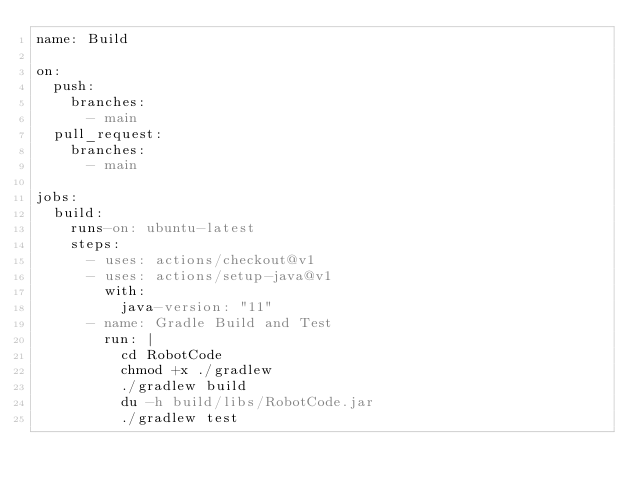<code> <loc_0><loc_0><loc_500><loc_500><_YAML_>name: Build

on:
  push:
    branches:
      - main
  pull_request:
    branches:
      - main

jobs:
  build:
    runs-on: ubuntu-latest
    steps:
      - uses: actions/checkout@v1
      - uses: actions/setup-java@v1
        with:
          java-version: "11"
      - name: Gradle Build and Test
        run: |
          cd RobotCode
          chmod +x ./gradlew
          ./gradlew build
          du -h build/libs/RobotCode.jar
          ./gradlew test
</code> 